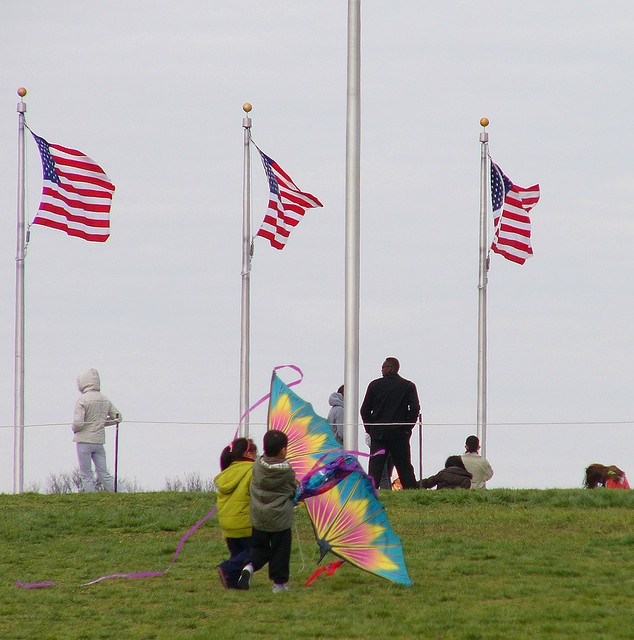Describe the objects in this image and their specific colors. I can see kite in lightgray, tan, brown, and teal tones, people in lightgray, black, darkgreen, gray, and maroon tones, people in lightgray, black, maroon, gray, and darkgray tones, people in lightgray, black, olive, and maroon tones, and people in lightgray, darkgray, and gray tones in this image. 